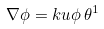<formula> <loc_0><loc_0><loc_500><loc_500>\nabla \phi = k u \phi \, \theta ^ { 1 }</formula> 